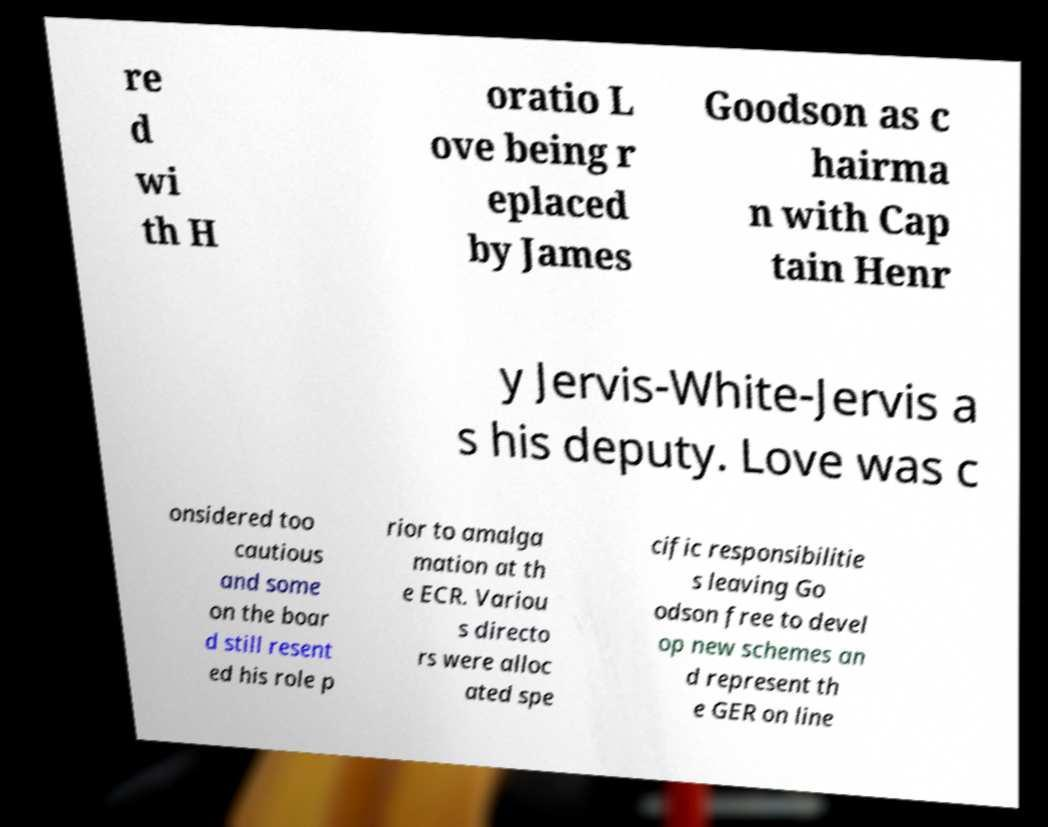For documentation purposes, I need the text within this image transcribed. Could you provide that? re d wi th H oratio L ove being r eplaced by James Goodson as c hairma n with Cap tain Henr y Jervis-White-Jervis a s his deputy. Love was c onsidered too cautious and some on the boar d still resent ed his role p rior to amalga mation at th e ECR. Variou s directo rs were alloc ated spe cific responsibilitie s leaving Go odson free to devel op new schemes an d represent th e GER on line 